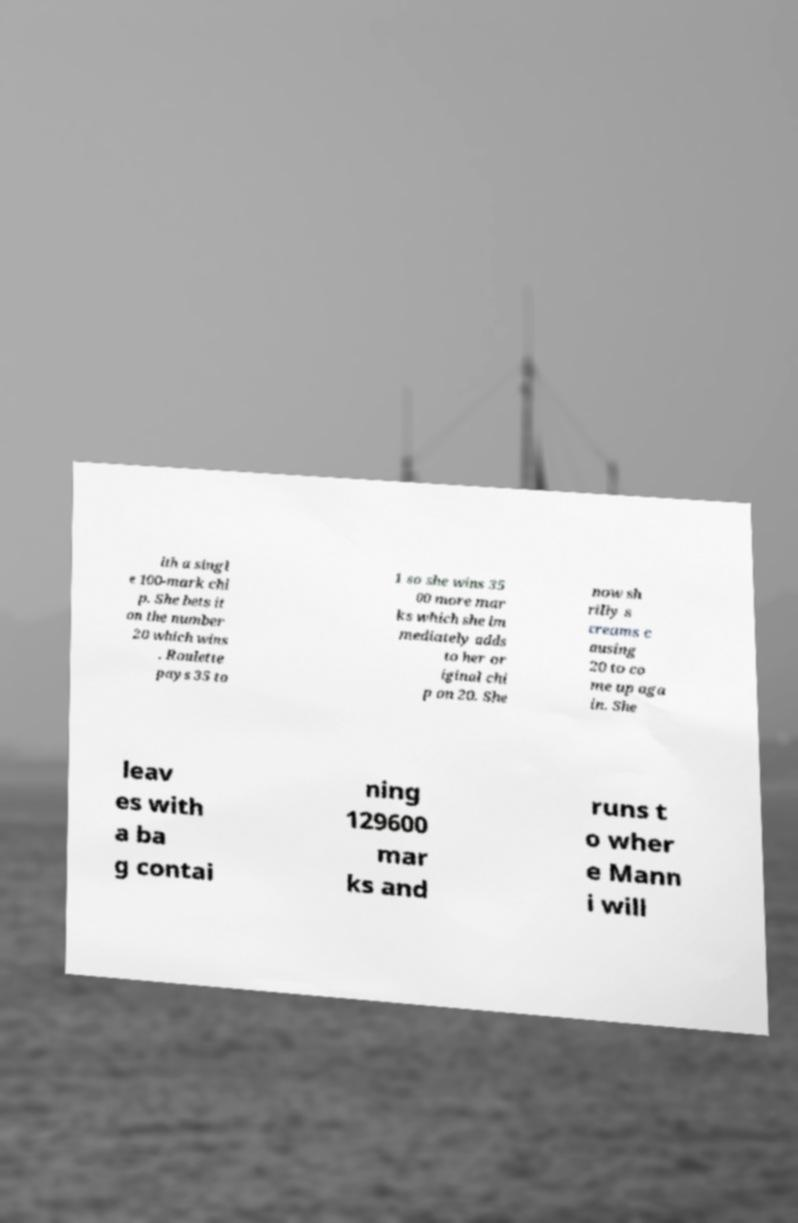For documentation purposes, I need the text within this image transcribed. Could you provide that? ith a singl e 100-mark chi p. She bets it on the number 20 which wins . Roulette pays 35 to 1 so she wins 35 00 more mar ks which she im mediately adds to her or iginal chi p on 20. She now sh rilly s creams c ausing 20 to co me up aga in. She leav es with a ba g contai ning 129600 mar ks and runs t o wher e Mann i will 